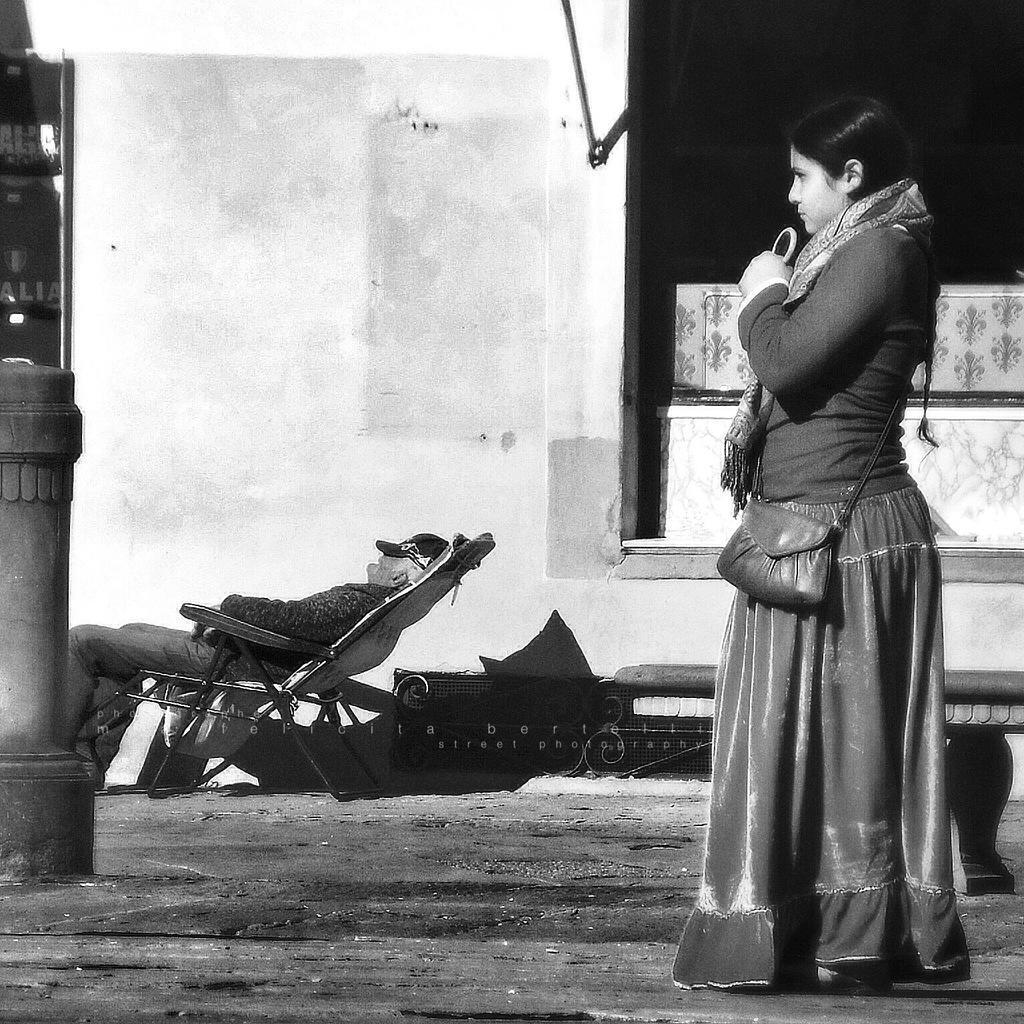Can you describe this image briefly? This picture seems to be clicked outside. On the right there is a woman wearing t-shirt, sling bag, holding an object and standing on the ground. On the left there is a person sitting in the chair and there are some objects placed on the ground. In the background there is a wall and some other objects. 